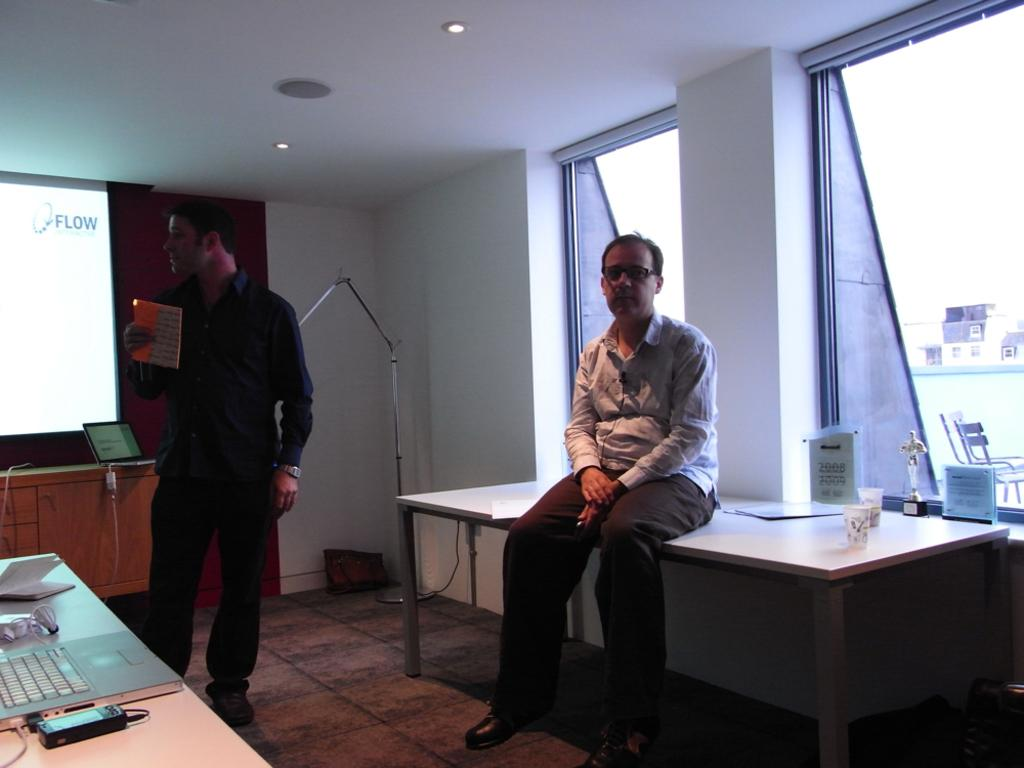What is the position of the man in the image? There is a man sitting on a table in the image. Can you describe the other man in the image? There is another man standing in the image. What is the standing man holding? The standing man is holding a book in his hand. What electronic device is present on the table in the image? There is a laptop on a table in the image. What else can be seen on the table with the laptop? There are papers on the table with the laptop. What type of animal can be seen interacting with the laptop in the image? There are no animals present in the image, and therefore no such interaction can be observed. How many lizards are sitting on the table with the man in the image? There are no lizards present in the image. 